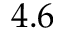<formula> <loc_0><loc_0><loc_500><loc_500>4 . 6</formula> 